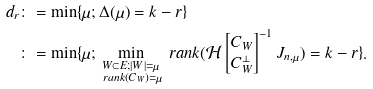<formula> <loc_0><loc_0><loc_500><loc_500>d _ { r } & \colon = \min \{ \mu ; \Delta ( \mu ) = k - r \} \\ & \colon = \min \{ \mu ; \min _ { \substack { W \subset E ; | W | = \mu \\ \ r a n k ( C _ { W } ) = \mu } } \ r a n k ( \mathcal { H } \begin{bmatrix} C _ { W } \\ C _ { W } ^ { \perp } \\ \end{bmatrix} ^ { - 1 } J _ { n , \mu } ) = k - r \} .</formula> 